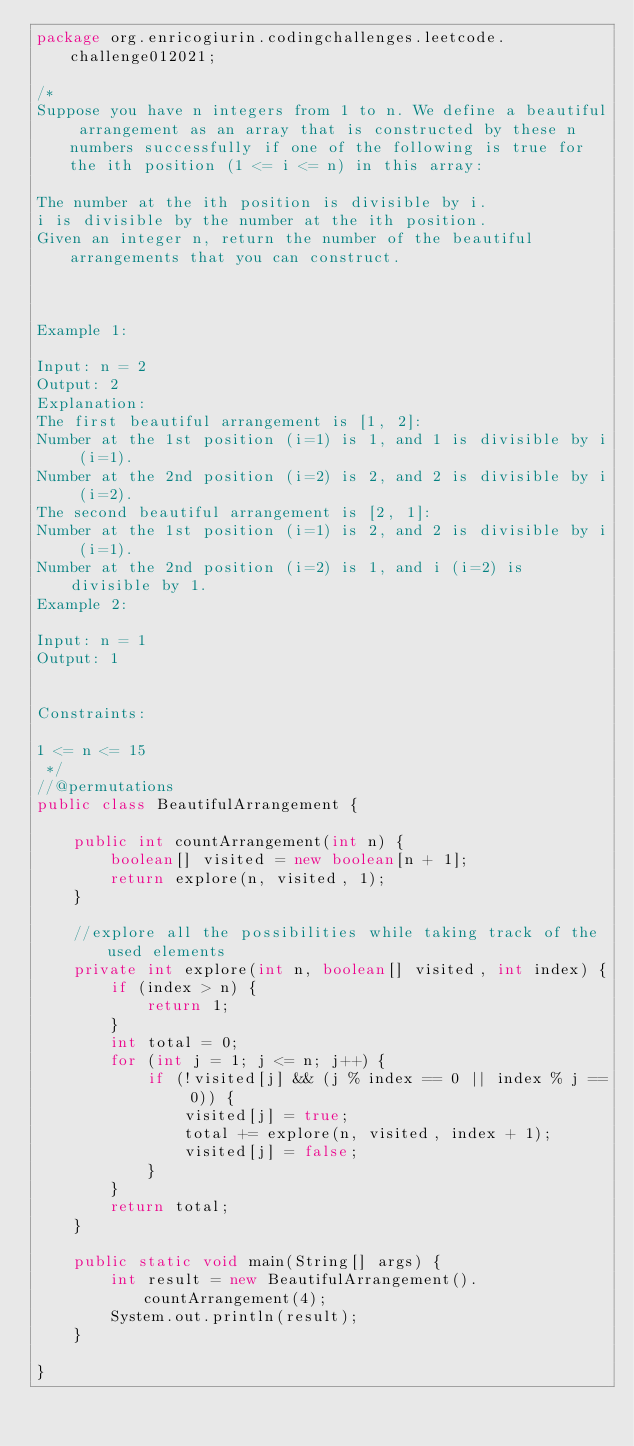Convert code to text. <code><loc_0><loc_0><loc_500><loc_500><_Java_>package org.enricogiurin.codingchallenges.leetcode.challenge012021;

/*
Suppose you have n integers from 1 to n. We define a beautiful arrangement as an array that is constructed by these n numbers successfully if one of the following is true for the ith position (1 <= i <= n) in this array:

The number at the ith position is divisible by i.
i is divisible by the number at the ith position.
Given an integer n, return the number of the beautiful arrangements that you can construct.



Example 1:

Input: n = 2
Output: 2
Explanation:
The first beautiful arrangement is [1, 2]:
Number at the 1st position (i=1) is 1, and 1 is divisible by i (i=1).
Number at the 2nd position (i=2) is 2, and 2 is divisible by i (i=2).
The second beautiful arrangement is [2, 1]:
Number at the 1st position (i=1) is 2, and 2 is divisible by i (i=1).
Number at the 2nd position (i=2) is 1, and i (i=2) is divisible by 1.
Example 2:

Input: n = 1
Output: 1


Constraints:

1 <= n <= 15
 */
//@permutations
public class BeautifulArrangement {

    public int countArrangement(int n) {
        boolean[] visited = new boolean[n + 1];
        return explore(n, visited, 1);
    }

    //explore all the possibilities while taking track of the used elements
    private int explore(int n, boolean[] visited, int index) {
        if (index > n) {
            return 1;
        }
        int total = 0;
        for (int j = 1; j <= n; j++) {
            if (!visited[j] && (j % index == 0 || index % j == 0)) {
                visited[j] = true;
                total += explore(n, visited, index + 1);
                visited[j] = false;
            }
        }
        return total;
    }

    public static void main(String[] args) {
        int result = new BeautifulArrangement().countArrangement(4);
        System.out.println(result);
    }

}
</code> 